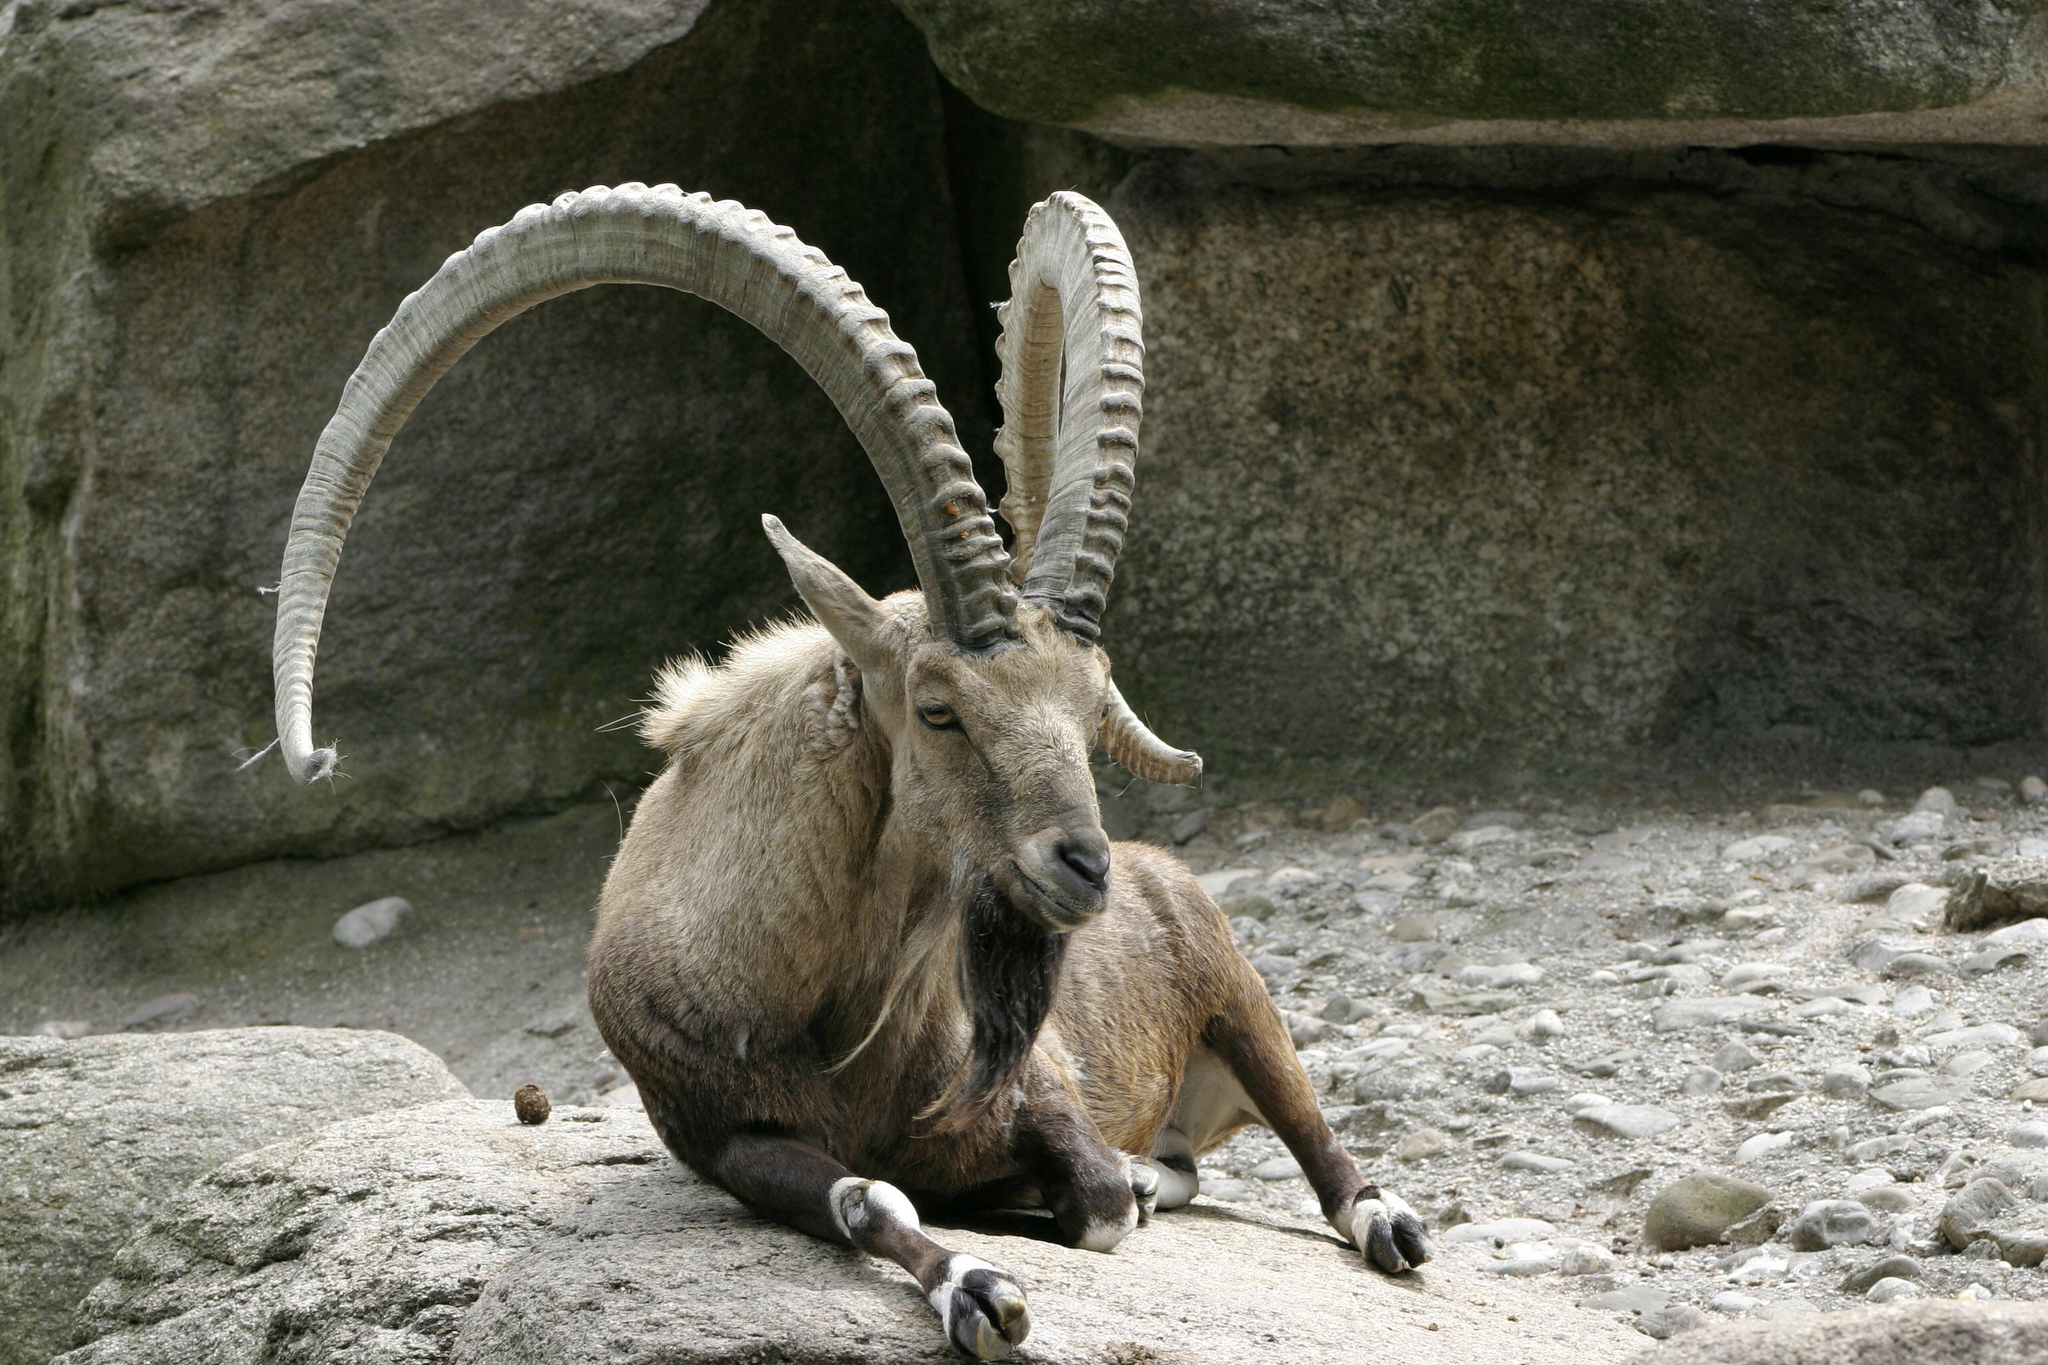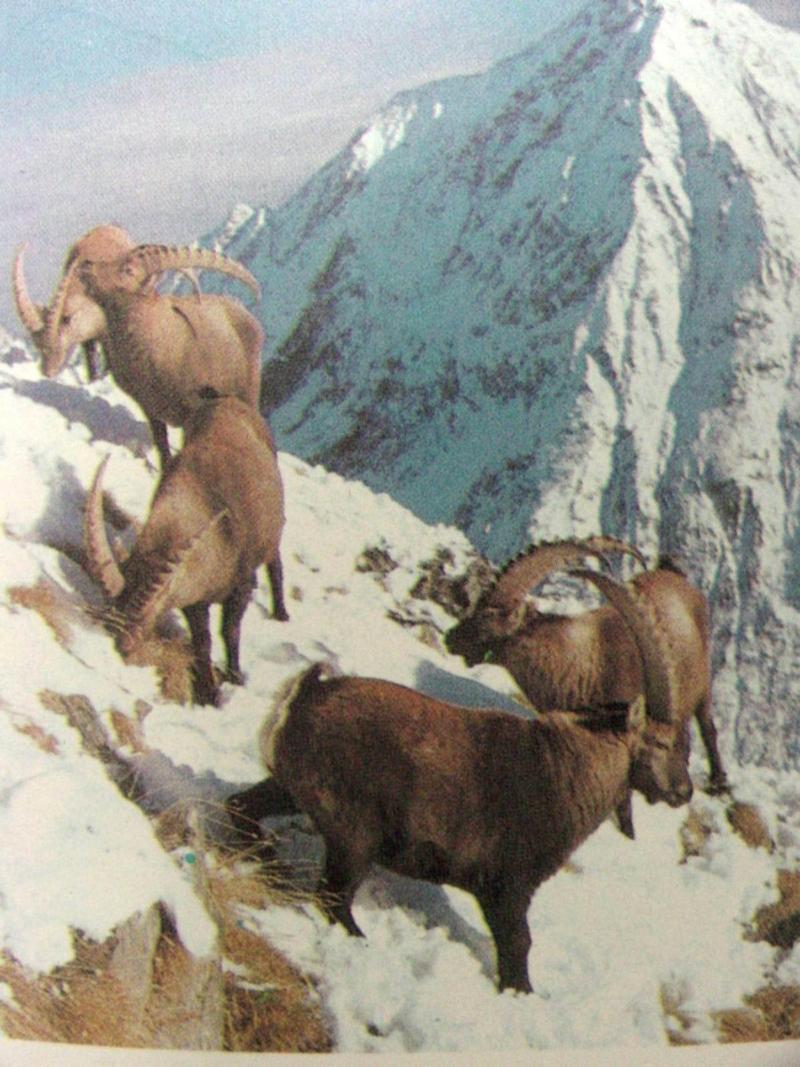The first image is the image on the left, the second image is the image on the right. For the images shown, is this caption "The right image contains exactly one mountain goat on a rocky cliff." true? Answer yes or no. No. The first image is the image on the left, the second image is the image on the right. Analyze the images presented: Is the assertion "There are more rams in the image on the left." valid? Answer yes or no. No. 